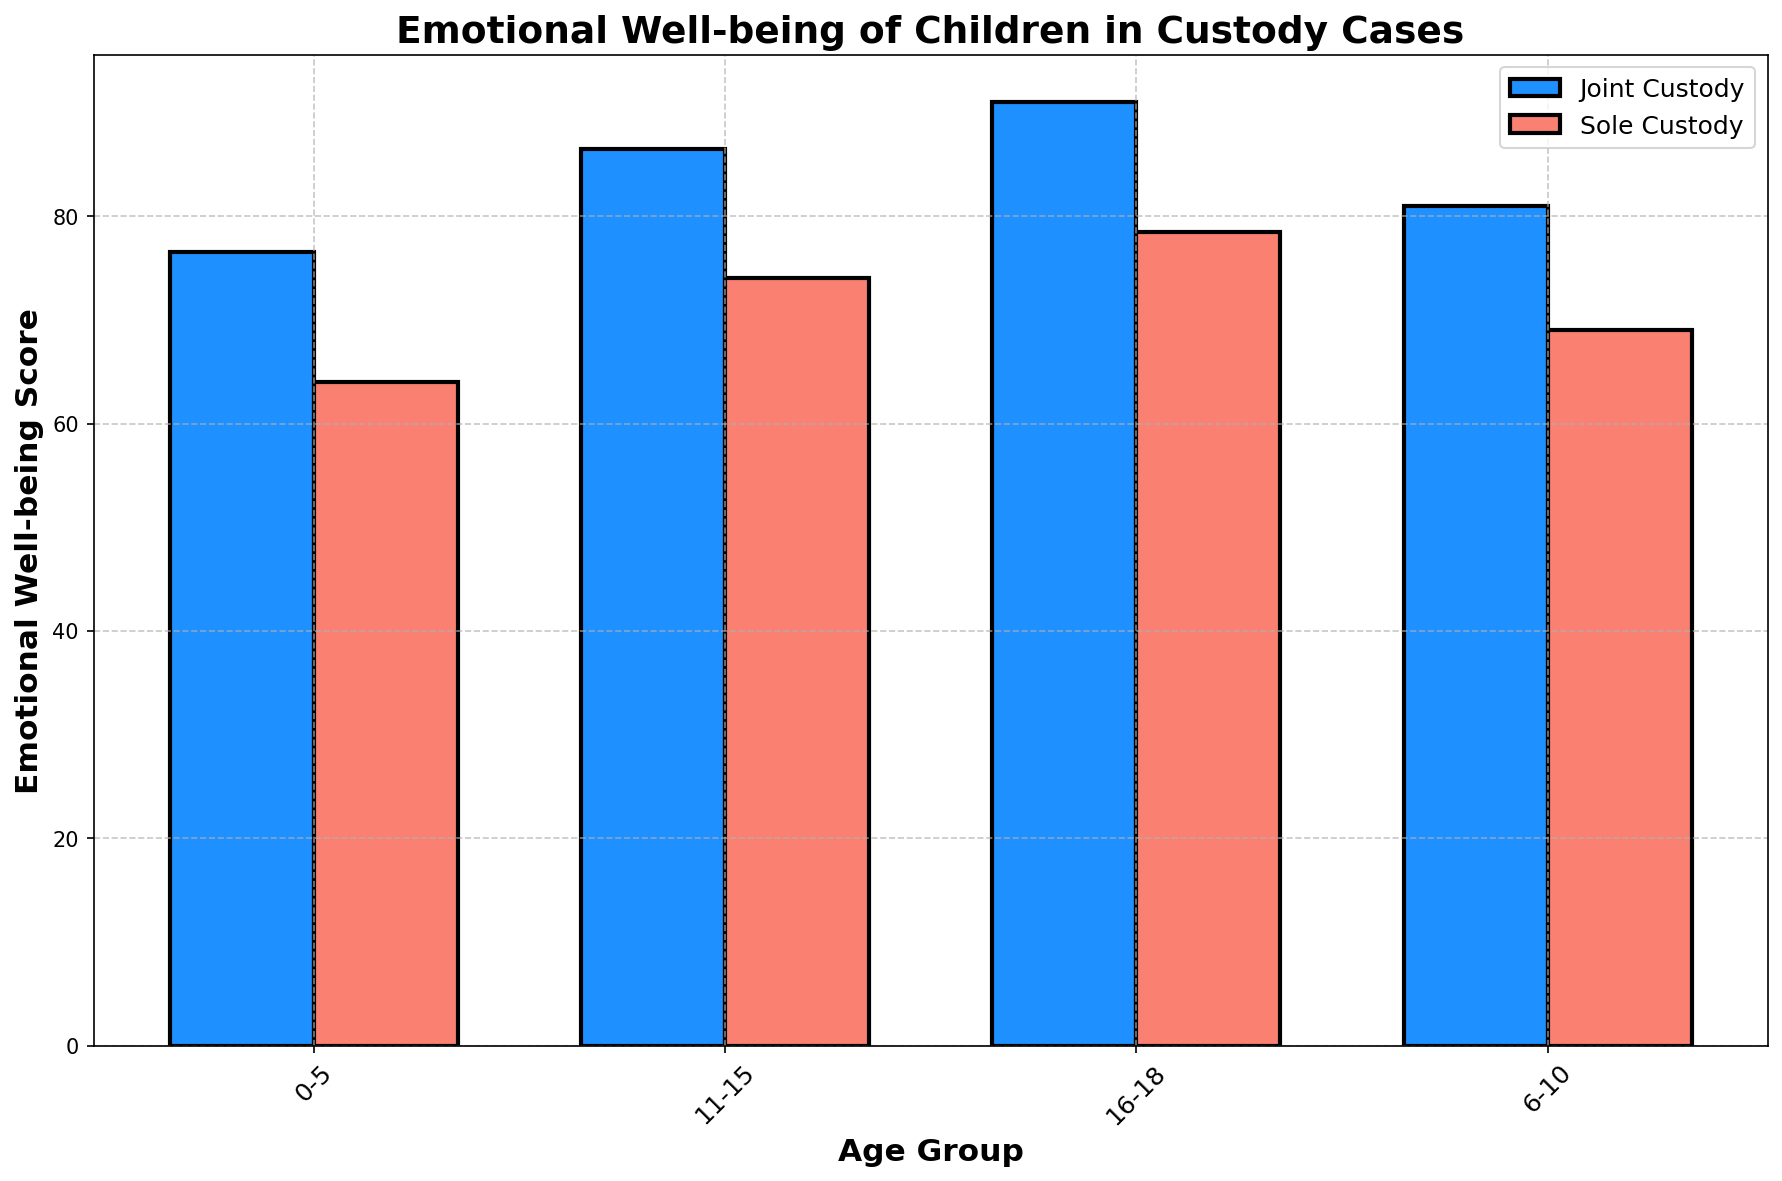What is the average emotional well-being score for children aged 0-5 in joint custody? First, identify the scores for children aged 0-5 in joint custody: 75 and 78. Then, calculate the average of these two scores: (75 + 78) / 2 = 76.5.
Answer: 76.5 Which age group shows the highest emotional well-being score in sole custody? Compare the emotional well-being scores in sole custody across all age groups: 65 (0-5), 70 (6-10), 75 (11-15), and 80 (16-18). The highest score is 80 in the 16-18 age group.
Answer: 16-18 Is there a consistent trend in emotional well-being as children age in joint custody cases? Analyze the scores for joint custody across the age groups: 75 (0-5), 80 (6-10), 85 (11-15), and 90 (16-18). The scores increase consistently with age.
Answer: Yes How much higher is the emotional well-being score for children aged 16-18 in joint custody compared to sole custody? Calculate the difference between the scores: 90 (joint) - 80 (sole) = 10 points higher.
Answer: 10 points Which custody type generally results in higher emotional well-being scores for children across all age groups? Compare the scores for joint custody and sole custody across all age groups: joint custody scores (75, 80, 85, 90), sole custody scores (65, 70, 75, 80). Joint custody scores are consistently higher.
Answer: Joint Custody What is the difference in emotional well-being scores between the youngest (0-5) and oldest (16-18) age groups in joint custody? Calculate the difference between the scores: 90 (16-18) - 75 (0-5) = 15 points.
Answer: 15 points Which age group shows the smallest difference in emotional well-being scores between joint and sole custody? Calculate the differences for each age group: 0-5 (75-65=10), 6-10 (80-70=10), 11-15 (85-75=10), 16-18 (90-80=10). The smallest difference is the same for all age groups, which is 10 points.
Answer: All age groups tied For children aged 6-10, what is the total emotional well-being score for both custody types combined? Add the scores for both joint and sole custody: 80 (joint) + 70 (sole) = 150.
Answer: 150 How do the emotional well-being scores vary between the 11-15 age group and the 6-10 age group in sole custody cases? Subtract the score for 11-15 age group (75) by the score for 6-10 age group (70): 75 - 70 = 5 points.
Answer: 5 points Which age group has the largest difference in emotional well-being scores between joint custody and sole custody cases, and what is the difference? Calculate the differences for each age group: 0-5 (10), 6-10 (10), 11-15 (10), 16-18 (10). Since all age groups have the same difference, the largest is 10 points.
Answer: All age groups tied, 10 points 